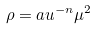<formula> <loc_0><loc_0><loc_500><loc_500>\rho = a u ^ { - n } \mu ^ { 2 }</formula> 